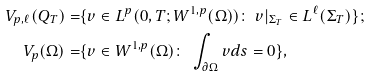<formula> <loc_0><loc_0><loc_500><loc_500>V _ { p , \ell } ( Q _ { T } ) = & \{ v \in L ^ { p } ( 0 , T ; W ^ { 1 , p } ( \Omega ) ) \colon \ v | _ { \Sigma _ { T } } \in L ^ { \ell } ( \Sigma _ { T } ) \} ; \\ V _ { p } ( \Omega ) = & \{ v \in W ^ { 1 , p } ( \Omega ) \colon \ \int _ { \partial \Omega } v d s = 0 \} ,</formula> 